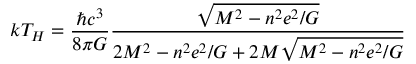<formula> <loc_0><loc_0><loc_500><loc_500>k T _ { H } = \frac { \hbar { c } ^ { 3 } } { 8 \pi G } \frac { \sqrt { M ^ { 2 } - n ^ { 2 } e ^ { 2 } / G } } { 2 M ^ { 2 } - n ^ { 2 } e ^ { 2 } / G + 2 M \sqrt { M ^ { 2 } - n ^ { 2 } e ^ { 2 } / G } }</formula> 